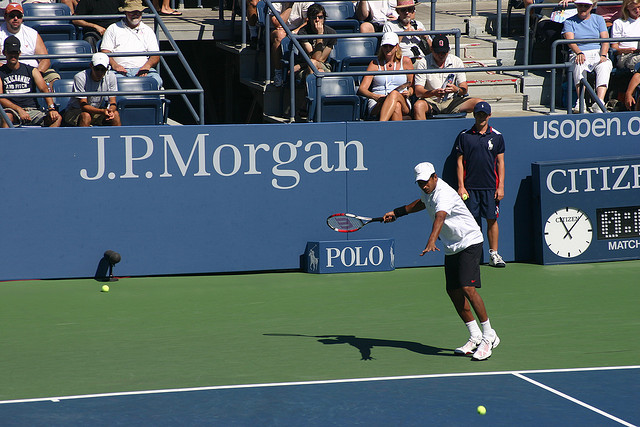Identify and read out the text in this image. J P. Morgan POLO usopen MATCH O CITIZEN CITIZEN 